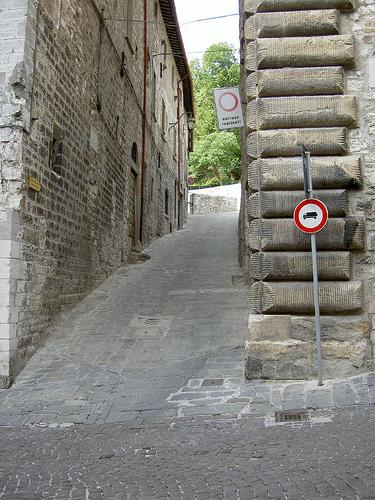Are there any cars on the street?
Concise answer only. No. Is this sign red?
Give a very brief answer. Yes. Is this a paved road?
Answer briefly. Yes. 